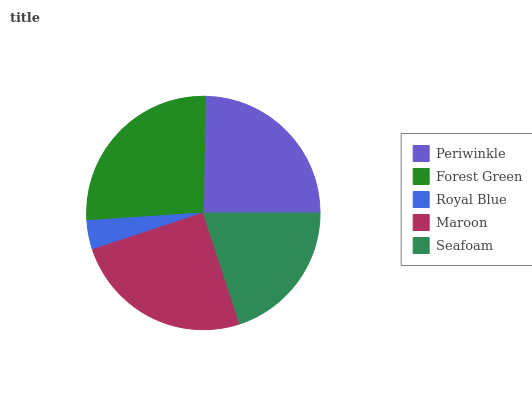Is Royal Blue the minimum?
Answer yes or no. Yes. Is Forest Green the maximum?
Answer yes or no. Yes. Is Forest Green the minimum?
Answer yes or no. No. Is Royal Blue the maximum?
Answer yes or no. No. Is Forest Green greater than Royal Blue?
Answer yes or no. Yes. Is Royal Blue less than Forest Green?
Answer yes or no. Yes. Is Royal Blue greater than Forest Green?
Answer yes or no. No. Is Forest Green less than Royal Blue?
Answer yes or no. No. Is Periwinkle the high median?
Answer yes or no. Yes. Is Periwinkle the low median?
Answer yes or no. Yes. Is Forest Green the high median?
Answer yes or no. No. Is Maroon the low median?
Answer yes or no. No. 